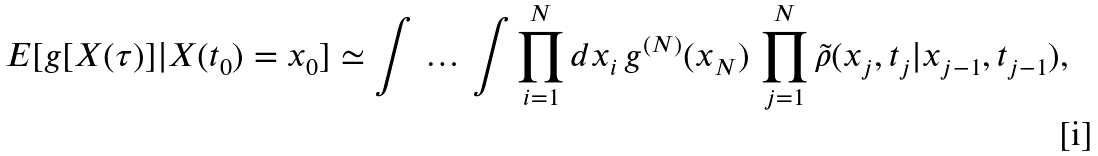<formula> <loc_0><loc_0><loc_500><loc_500>E [ g [ X ( \tau ) ] | X ( t _ { 0 } ) = x _ { 0 } ] \simeq \int \, \dots \, \int \prod _ { i = 1 } ^ { N } d x _ { i } \, g ^ { ( N ) } ( x _ { N } ) \, \prod _ { j = 1 } ^ { N } { \tilde { \rho } } ( x _ { j } , t _ { j } | x _ { j - 1 } , t _ { j - 1 } ) ,</formula> 